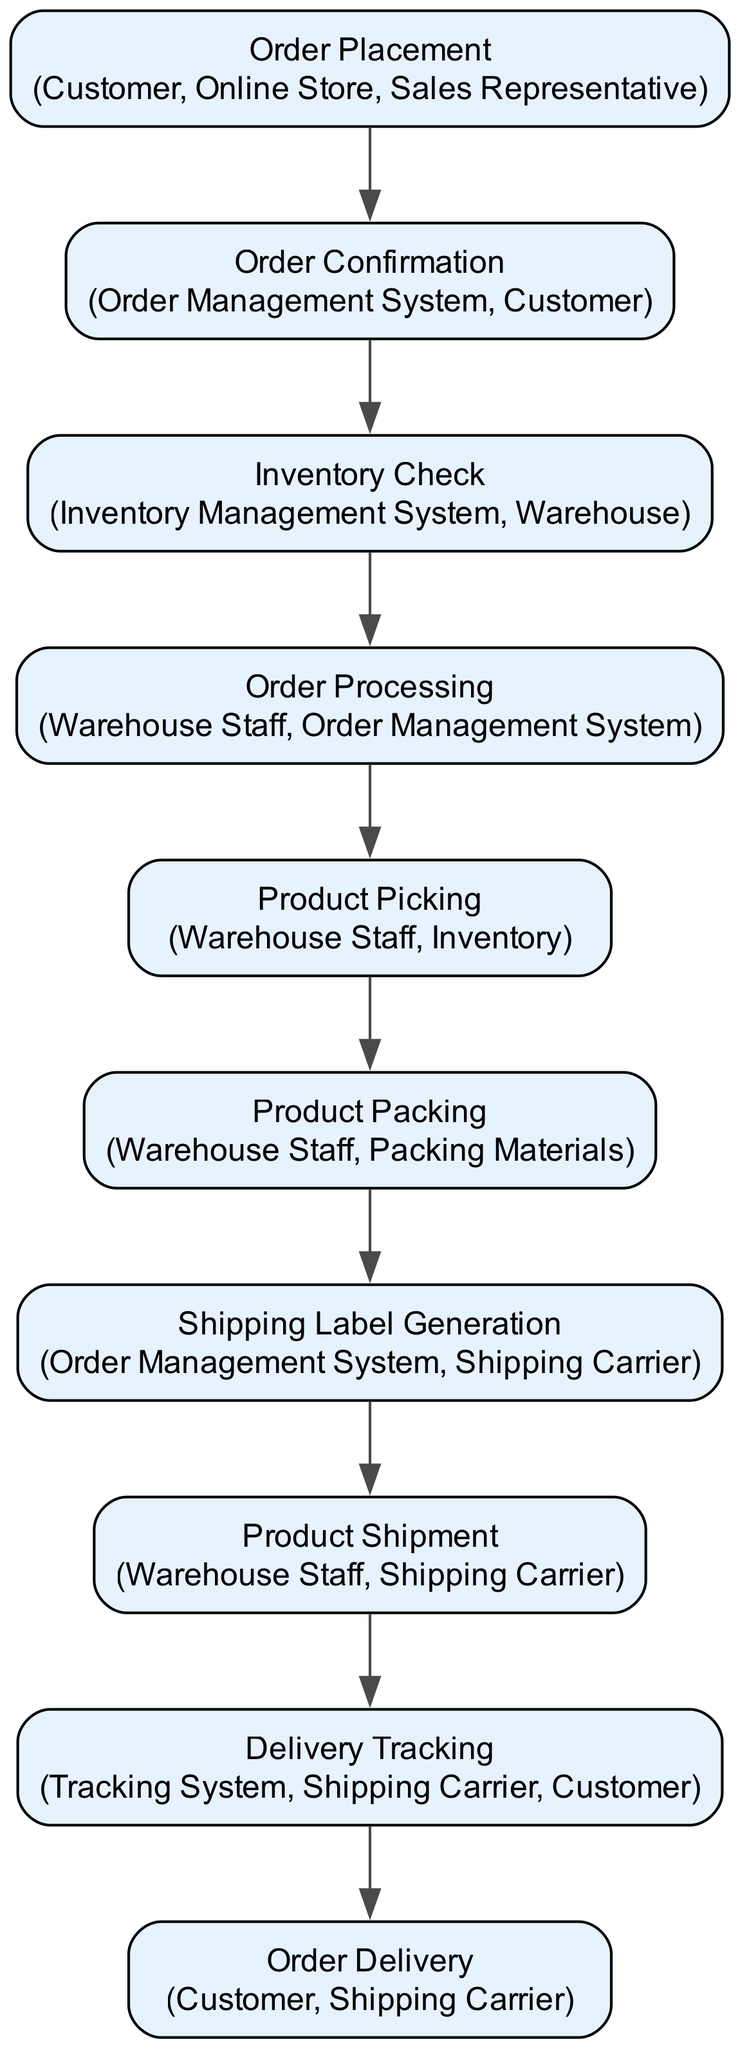What is the first step in the workflow? The first step in the diagram is "Order Placement", where the customer places an order through the online store or sales representative.
Answer: Order Placement How many entities are involved in "Product Packing"? The "Product Packing" node lists two entities, which are "Warehouse Staff" and "Packing Materials". Counting these gives a total of 2 entities.
Answer: 2 Which node follows "Inventory Check"? After "Inventory Check", the next node is "Order Processing". This is a direct progression based on the connection in the diagram.
Answer: Order Processing What is the last step before "Order Delivery"? The last step before "Order Delivery" is "Product Shipment". This indicates the process just before the delivery to the customer.
Answer: Product Shipment Which entities are involved in "Delivery Tracking"? The entities mentioned in "Delivery Tracking" are "Tracking System", "Shipping Carrier", and "Customer". This requires checking the relevant node for all associated entities.
Answer: Tracking System, Shipping Carrier, Customer What happens after "Order Confirmation"? Following "Order Confirmation", the next step is "Inventory Check". This denotes the sequential flow from confirming the order to checking inventory levels.
Answer: Inventory Check How many steps are there in the entire workflow? Counting all the nodes listed in the diagram constitutes 10 distinct steps, from "Order Placement" to "Order Delivery".
Answer: 10 Which step includes generating shipping labels? The step that involves generating shipping labels is "Shipping Label Generation". This can be identified directly under the related node in the diagram.
Answer: Shipping Label Generation What is the key action taken by the "Warehouse Staff" during "Product Picking"? The key action taken during "Product Picking" is to "pick products from inventory based on picking list". This specifies the role of warehouse staff at this stage.
Answer: Pick products from inventory based on picking list 